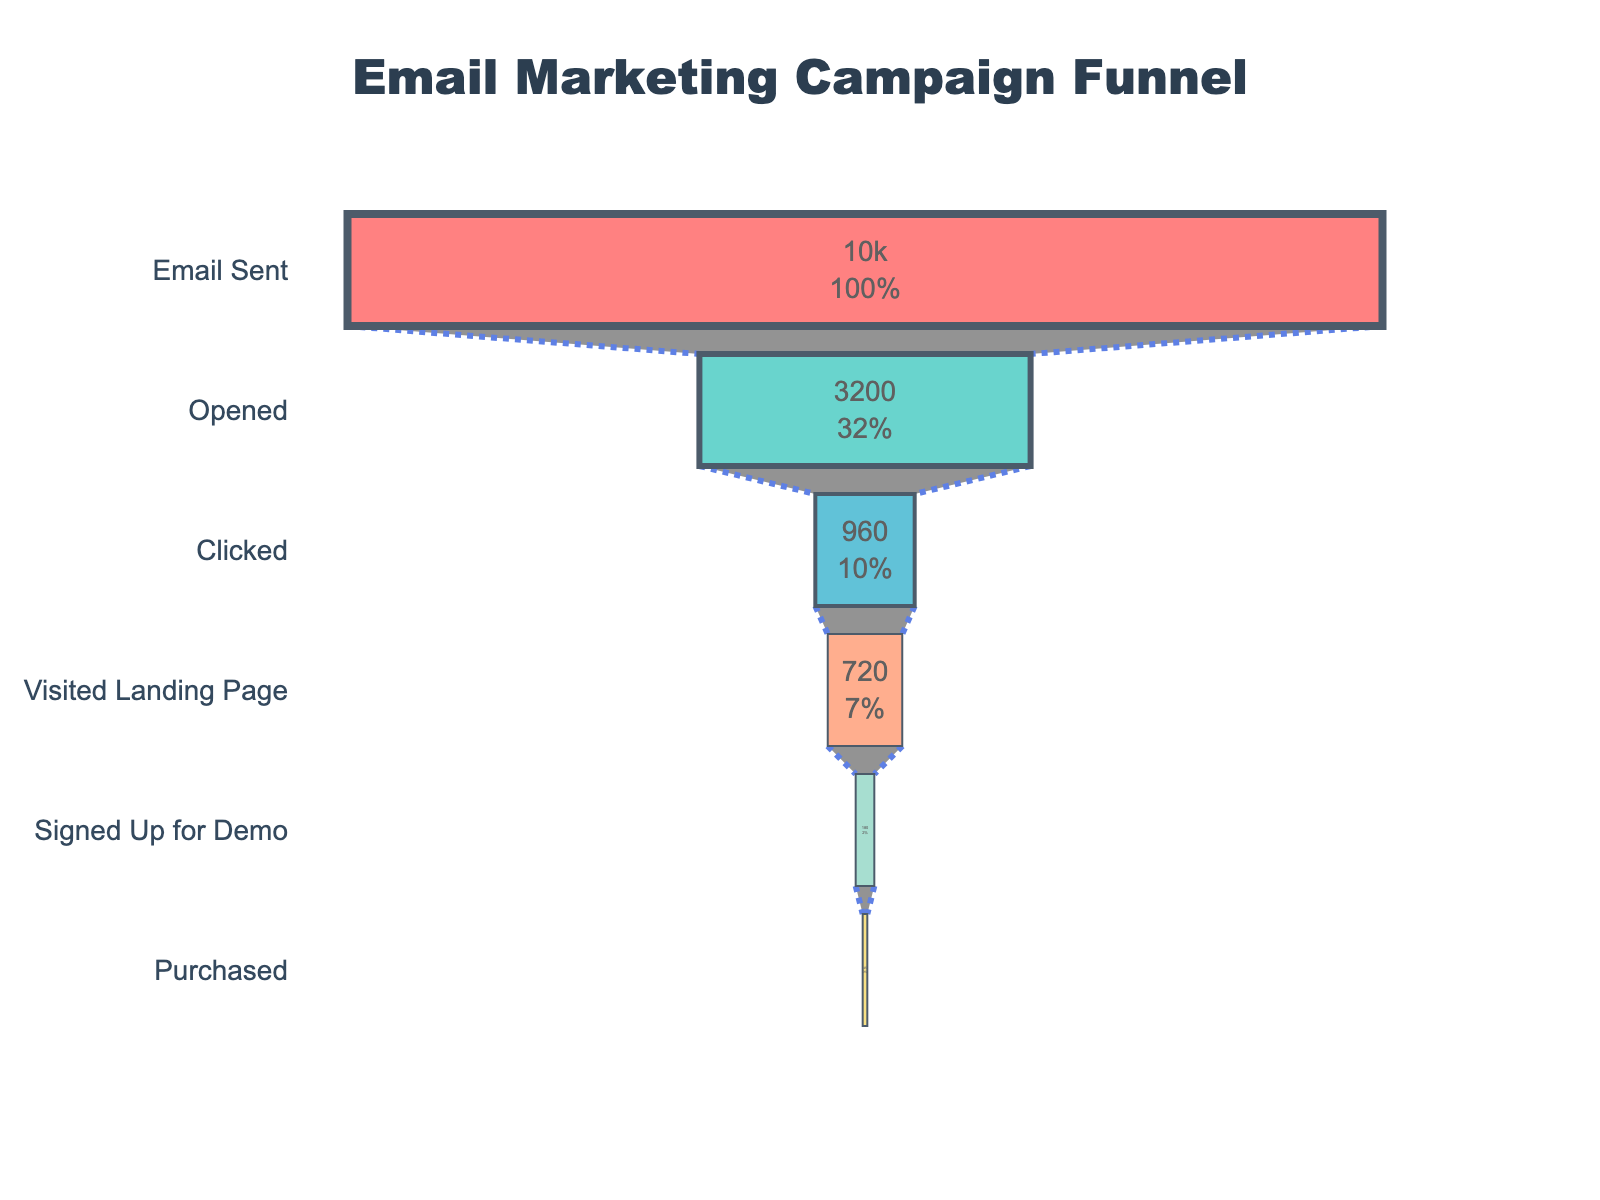What is the title of the funnel chart? The title is located at the very top of the funnel chart and is typically in larger and more prominent font.
Answer: Email Marketing Campaign Funnel How many stages are there in the funnel chart? By counting the distinct horizontal bars in the funnel chart, we can determine the number of stages.
Answer: Six What percentage of emails sent were opened? To find the percentage, locate the 'Opened' stage bar and read the percentage value displayed on it.
Answer: 32% What is the difference in count between the Clicked and Purchased stages? Subtract the count of the Purchased stage from the Clicked stage: 960 (Clicked) - 45 (Purchased) = 915.
Answer: 915 Which stage had the lowest count and what was that count? Identify the bar with the smallest length and check the count displayed within or alongside it.
Answer: Purchased, 45 What is the primary color used for the 'Visited Landing Page' stage in the funnel? Look for the bar representing the 'Visited Landing Page' stage and note its color.
Answer: Light coral (#FFA07A) How does the count on the Signed Up for Demo stage compare to the Visited Landing Page stage? Compare the values displayed on both stages to see the difference.
Answer: 540 less (720 - 180) How many people moved from clicking the email to visiting the landing page? Subtract the count of the Visited Landing Page stage from the count of the Clicked stage: 960 (Clicked) - 720 (Visited Landing Page) = 240.
Answer: 240 What is the trend observed as you move down the funnel stages? Review the counts and percentages as you move from the top to the bottom of the funnel to identify a pattern.
Answer: Decreasing How many people transitioned from the Signed Up for Demo stage to the Purchased stage? Subtract the count of the Purchased stage from the Signed Up for Demo stage: 180 (Signed Up for Demo) - 45 (Purchased) = 135.
Answer: 135 